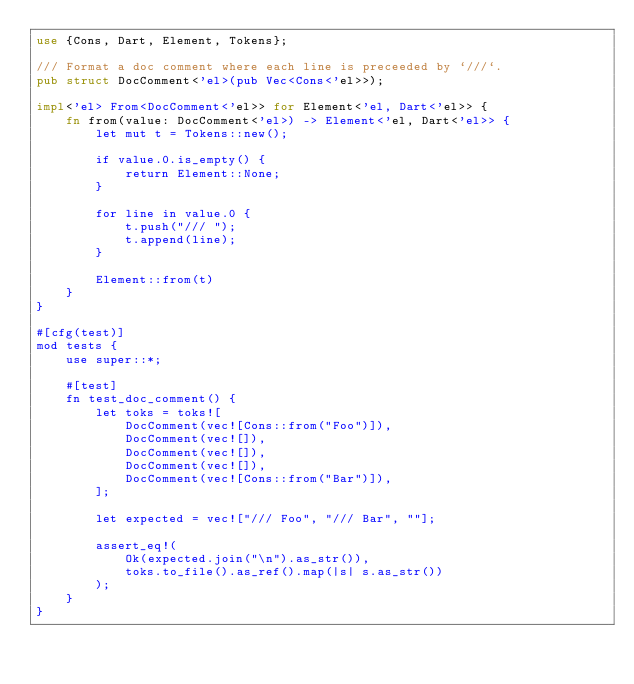Convert code to text. <code><loc_0><loc_0><loc_500><loc_500><_Rust_>use {Cons, Dart, Element, Tokens};

/// Format a doc comment where each line is preceeded by `///`.
pub struct DocComment<'el>(pub Vec<Cons<'el>>);

impl<'el> From<DocComment<'el>> for Element<'el, Dart<'el>> {
    fn from(value: DocComment<'el>) -> Element<'el, Dart<'el>> {
        let mut t = Tokens::new();

        if value.0.is_empty() {
            return Element::None;
        }

        for line in value.0 {
            t.push("/// ");
            t.append(line);
        }

        Element::from(t)
    }
}

#[cfg(test)]
mod tests {
    use super::*;

    #[test]
    fn test_doc_comment() {
        let toks = toks![
            DocComment(vec![Cons::from("Foo")]),
            DocComment(vec![]),
            DocComment(vec![]),
            DocComment(vec![]),
            DocComment(vec![Cons::from("Bar")]),
        ];

        let expected = vec!["/// Foo", "/// Bar", ""];

        assert_eq!(
            Ok(expected.join("\n").as_str()),
            toks.to_file().as_ref().map(|s| s.as_str())
        );
    }
}
</code> 